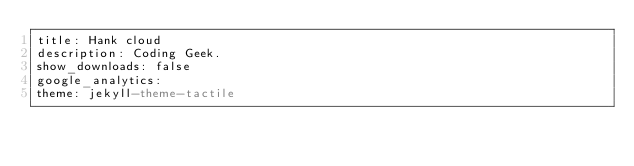Convert code to text. <code><loc_0><loc_0><loc_500><loc_500><_YAML_>title: Hank cloud
description: Coding Geek.
show_downloads: false
google_analytics:
theme: jekyll-theme-tactile</code> 